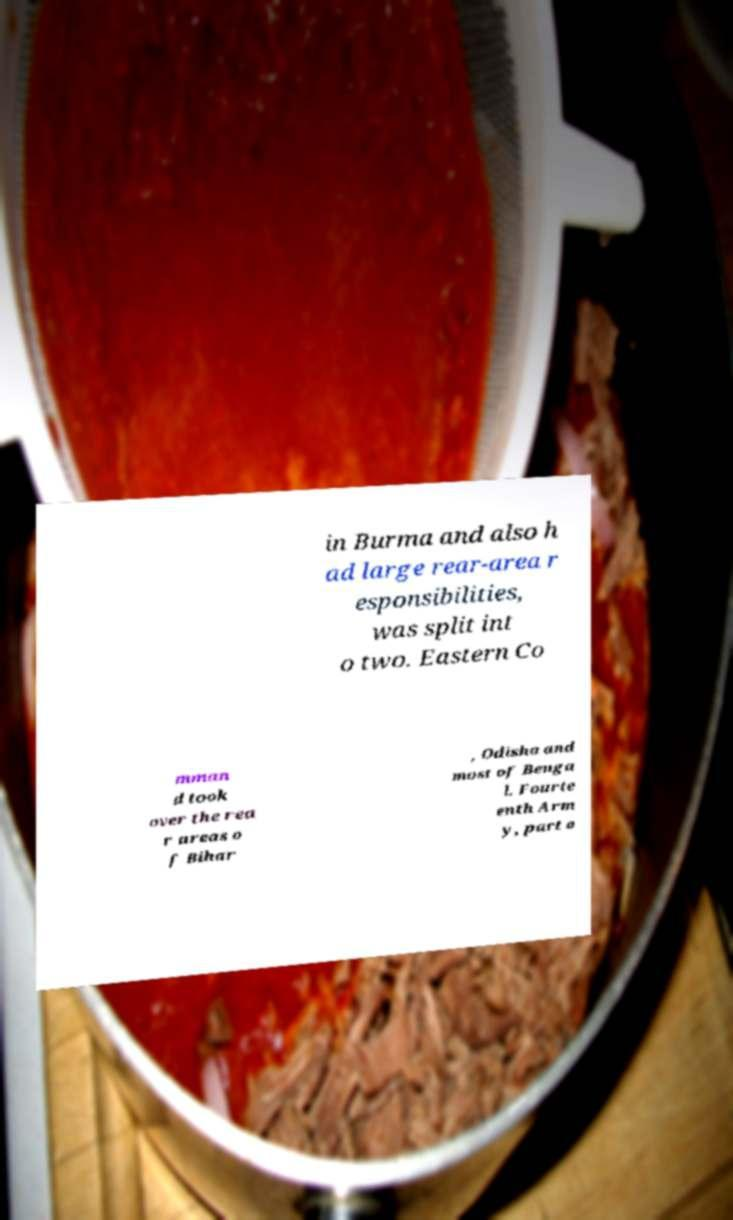Can you read and provide the text displayed in the image?This photo seems to have some interesting text. Can you extract and type it out for me? in Burma and also h ad large rear-area r esponsibilities, was split int o two. Eastern Co mman d took over the rea r areas o f Bihar , Odisha and most of Benga l. Fourte enth Arm y, part o 